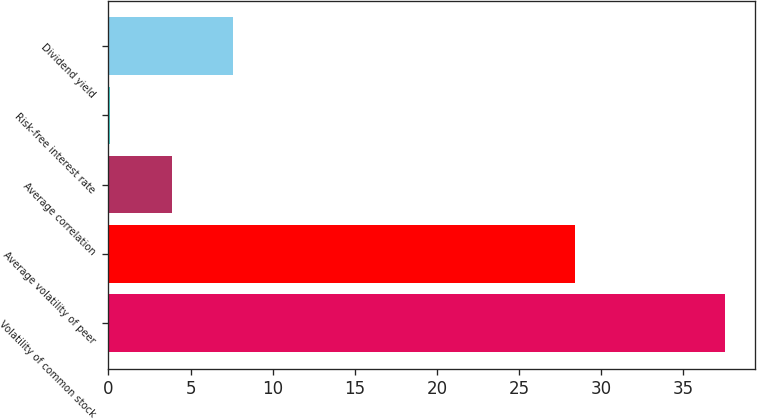Convert chart. <chart><loc_0><loc_0><loc_500><loc_500><bar_chart><fcel>Volatility of common stock<fcel>Average volatility of peer<fcel>Average correlation<fcel>Risk-free interest rate<fcel>Dividend yield<nl><fcel>37.51<fcel>28.42<fcel>3.86<fcel>0.12<fcel>7.6<nl></chart> 